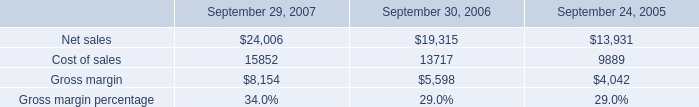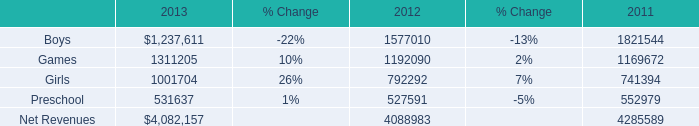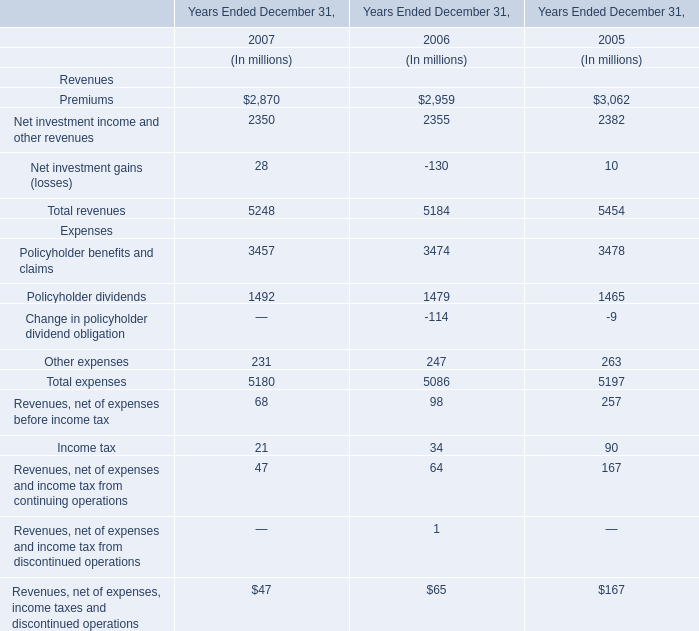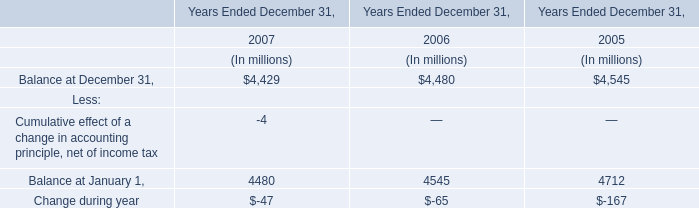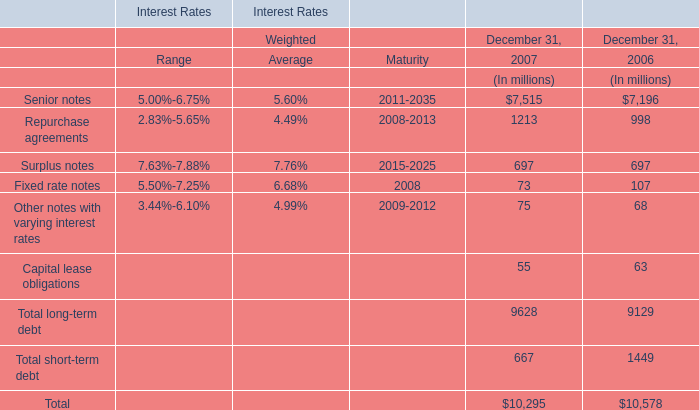What is the sum of the Policyholder benefits and claims in the years where Premiums is positive? (in million) 
Computations: ((3457 + 3474) + 3478)
Answer: 10409.0. 